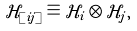<formula> <loc_0><loc_0><loc_500><loc_500>\mathcal { H } _ { [ i j ] } \equiv \mathcal { H } _ { i } \otimes \mathcal { H } _ { j } ,</formula> 